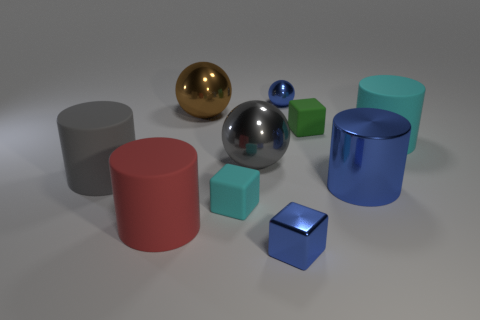Subtract all blue spheres. How many spheres are left? 2 Subtract all blue cylinders. How many cylinders are left? 3 Subtract 1 balls. How many balls are left? 2 Subtract all green cylinders. Subtract all blue spheres. How many cylinders are left? 4 Subtract all spheres. How many objects are left? 7 Add 3 shiny objects. How many shiny objects exist? 8 Subtract 1 cyan blocks. How many objects are left? 9 Subtract all big yellow metallic blocks. Subtract all big brown objects. How many objects are left? 9 Add 5 big blue shiny things. How many big blue shiny things are left? 6 